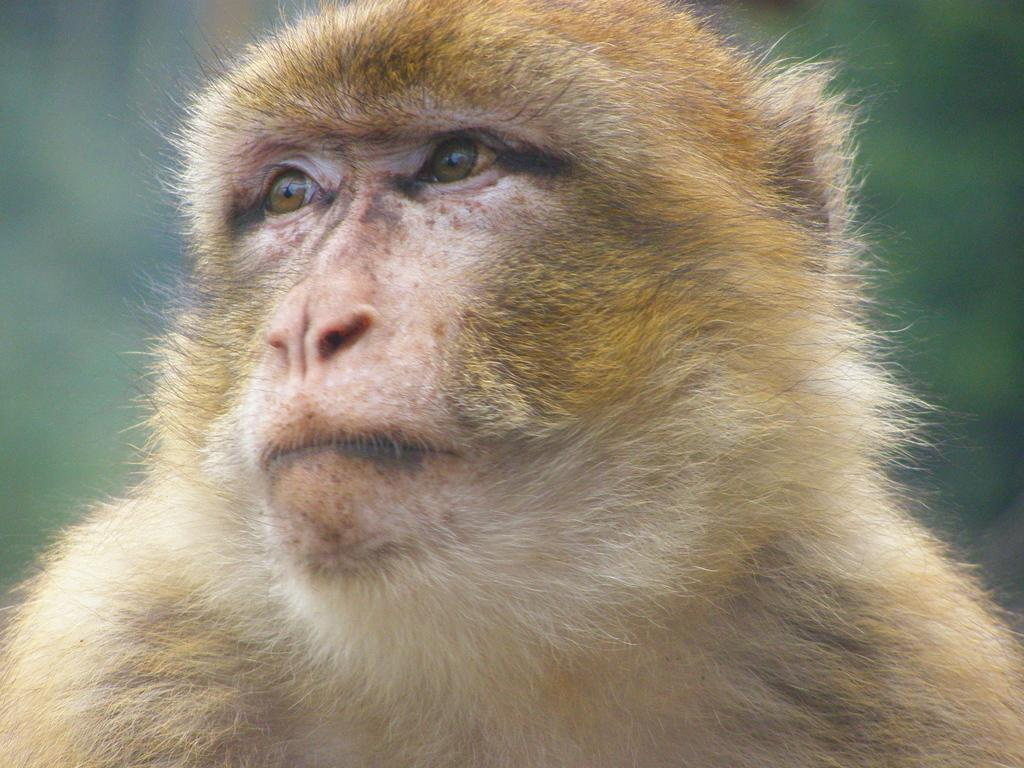What animal is the main subject of the image? There is a monkey in the image. Can you describe the background of the image? The background of the image is blurry. What type of birth announcement is visible in the image? There is no birth announcement present in the image; it features a monkey with a blurry background. What kind of attraction can be seen in the image? There is no attraction present in the image; it features a monkey with a blurry background. 